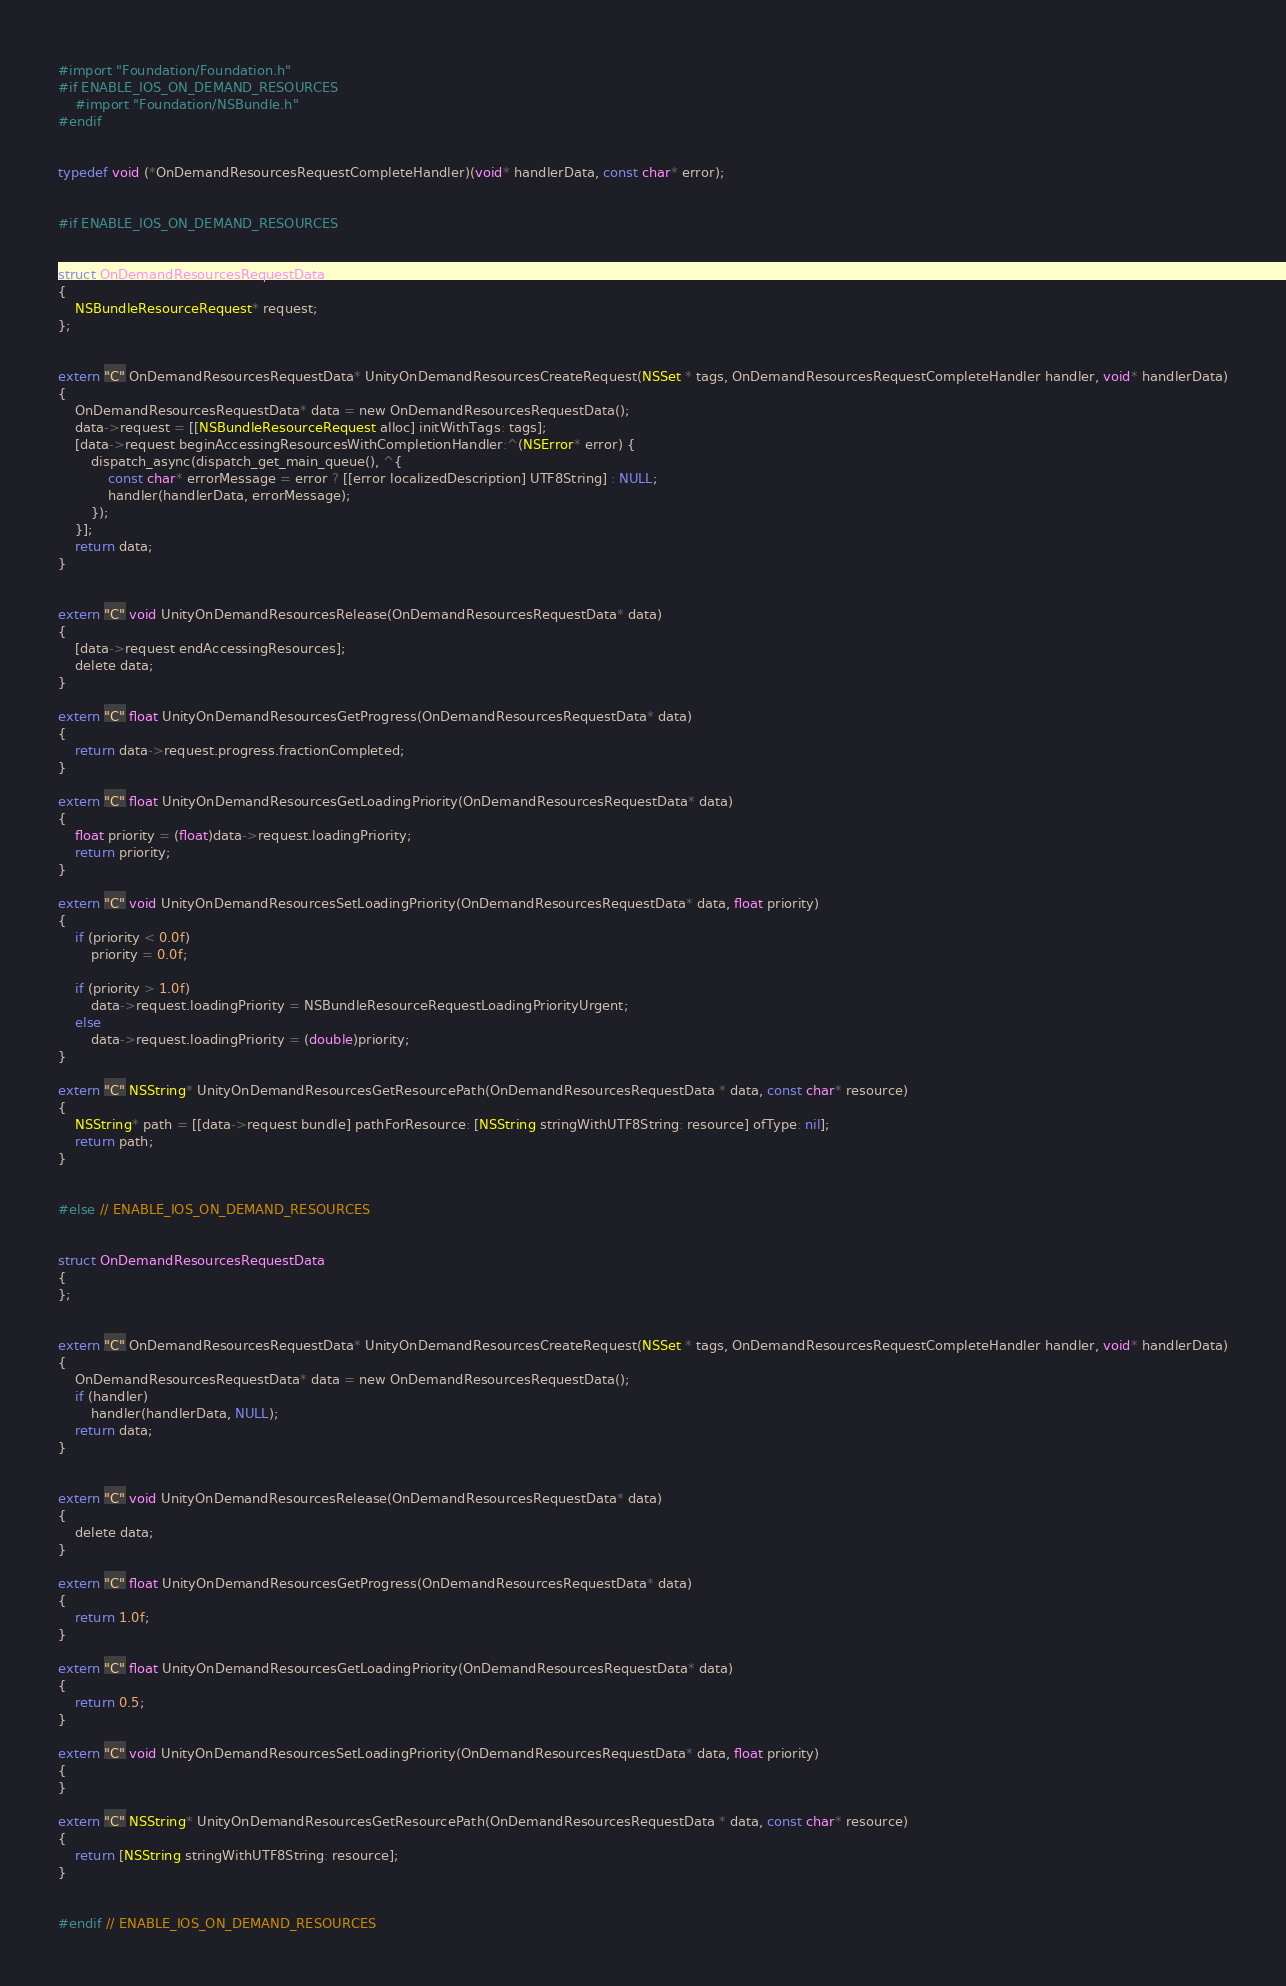<code> <loc_0><loc_0><loc_500><loc_500><_ObjectiveC_>#import "Foundation/Foundation.h"
#if ENABLE_IOS_ON_DEMAND_RESOURCES
    #import "Foundation/NSBundle.h"
#endif


typedef void (*OnDemandResourcesRequestCompleteHandler)(void* handlerData, const char* error);


#if ENABLE_IOS_ON_DEMAND_RESOURCES


struct OnDemandResourcesRequestData
{
    NSBundleResourceRequest* request;
};


extern "C" OnDemandResourcesRequestData* UnityOnDemandResourcesCreateRequest(NSSet * tags, OnDemandResourcesRequestCompleteHandler handler, void* handlerData)
{
    OnDemandResourcesRequestData* data = new OnDemandResourcesRequestData();
    data->request = [[NSBundleResourceRequest alloc] initWithTags: tags];
    [data->request beginAccessingResourcesWithCompletionHandler:^(NSError* error) {
        dispatch_async(dispatch_get_main_queue(), ^{
            const char* errorMessage = error ? [[error localizedDescription] UTF8String] : NULL;
            handler(handlerData, errorMessage);
        });
    }];
    return data;
}


extern "C" void UnityOnDemandResourcesRelease(OnDemandResourcesRequestData* data)
{
    [data->request endAccessingResources];
    delete data;
}

extern "C" float UnityOnDemandResourcesGetProgress(OnDemandResourcesRequestData* data)
{
    return data->request.progress.fractionCompleted;
}

extern "C" float UnityOnDemandResourcesGetLoadingPriority(OnDemandResourcesRequestData* data)
{
    float priority = (float)data->request.loadingPriority;
    return priority;
}

extern "C" void UnityOnDemandResourcesSetLoadingPriority(OnDemandResourcesRequestData* data, float priority)
{
    if (priority < 0.0f)
        priority = 0.0f;

    if (priority > 1.0f)
        data->request.loadingPriority = NSBundleResourceRequestLoadingPriorityUrgent;
    else
        data->request.loadingPriority = (double)priority;
}

extern "C" NSString* UnityOnDemandResourcesGetResourcePath(OnDemandResourcesRequestData * data, const char* resource)
{
    NSString* path = [[data->request bundle] pathForResource: [NSString stringWithUTF8String: resource] ofType: nil];
    return path;
}


#else // ENABLE_IOS_ON_DEMAND_RESOURCES


struct OnDemandResourcesRequestData
{
};


extern "C" OnDemandResourcesRequestData* UnityOnDemandResourcesCreateRequest(NSSet * tags, OnDemandResourcesRequestCompleteHandler handler, void* handlerData)
{
    OnDemandResourcesRequestData* data = new OnDemandResourcesRequestData();
    if (handler)
        handler(handlerData, NULL);
    return data;
}


extern "C" void UnityOnDemandResourcesRelease(OnDemandResourcesRequestData* data)
{
    delete data;
}

extern "C" float UnityOnDemandResourcesGetProgress(OnDemandResourcesRequestData* data)
{
    return 1.0f;
}

extern "C" float UnityOnDemandResourcesGetLoadingPriority(OnDemandResourcesRequestData* data)
{
    return 0.5;
}

extern "C" void UnityOnDemandResourcesSetLoadingPriority(OnDemandResourcesRequestData* data, float priority)
{
}

extern "C" NSString* UnityOnDemandResourcesGetResourcePath(OnDemandResourcesRequestData * data, const char* resource)
{
    return [NSString stringWithUTF8String: resource];
}


#endif // ENABLE_IOS_ON_DEMAND_RESOURCES
</code> 